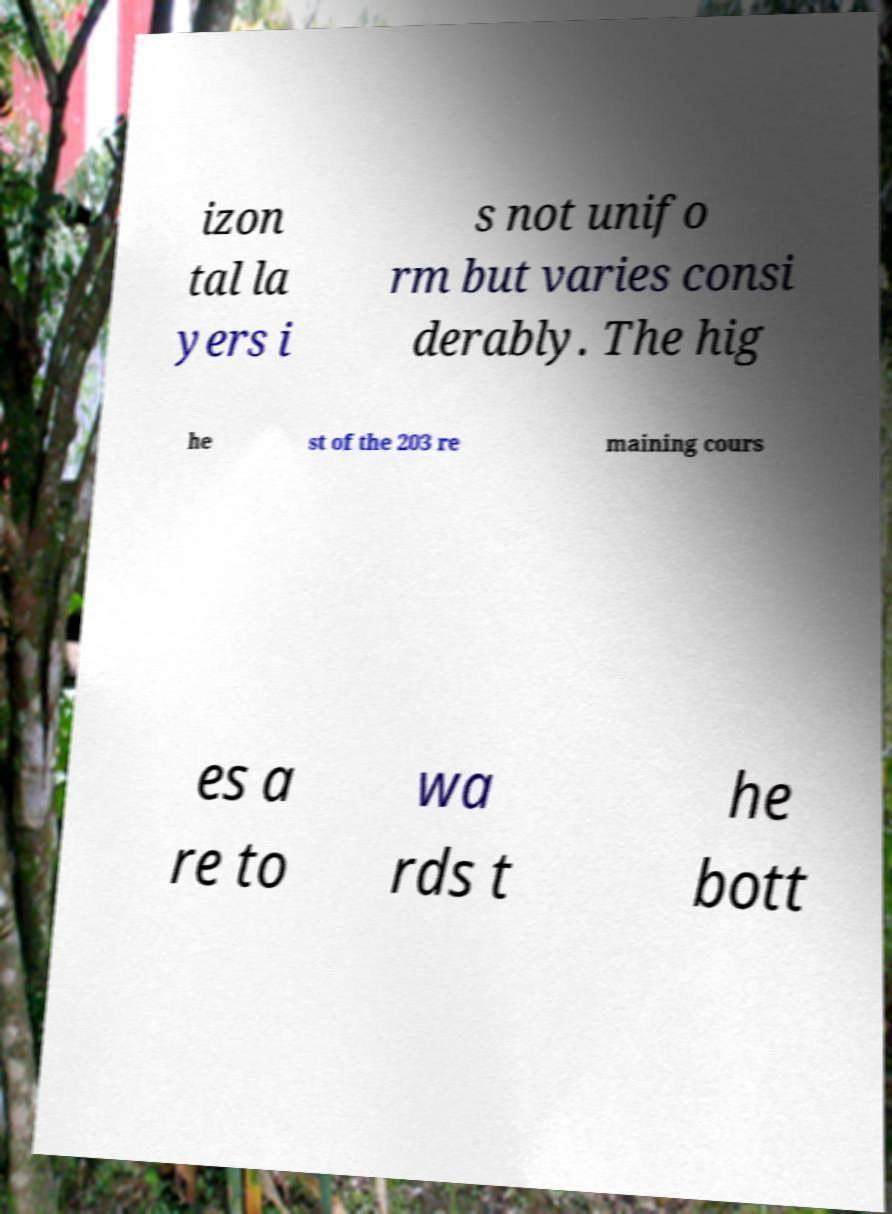I need the written content from this picture converted into text. Can you do that? izon tal la yers i s not unifo rm but varies consi derably. The hig he st of the 203 re maining cours es a re to wa rds t he bott 